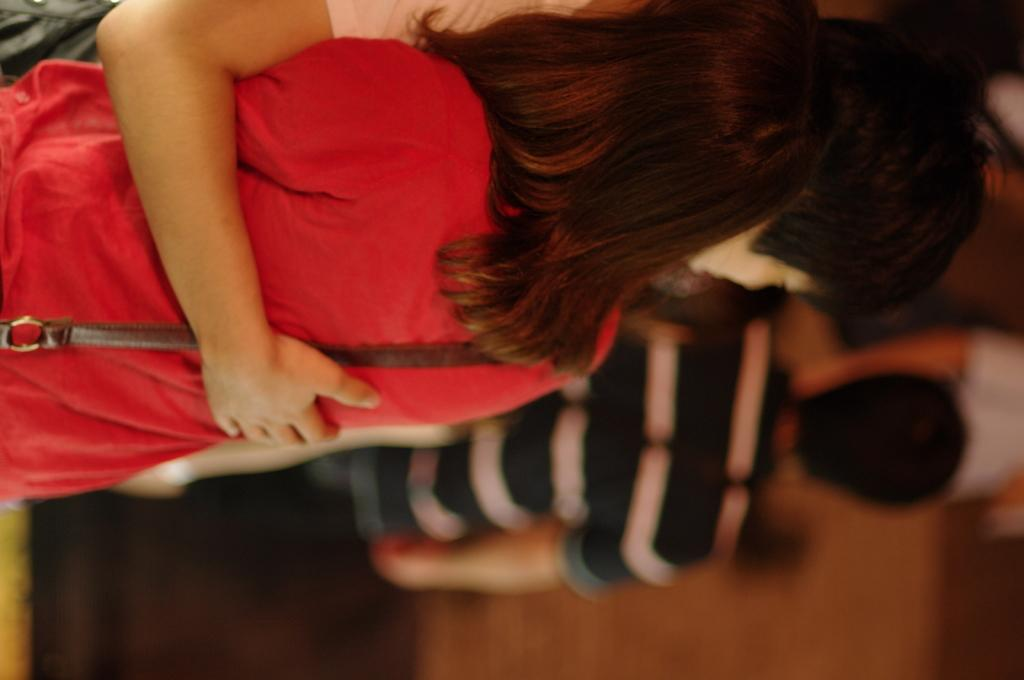What are the two people in the foreground of the image doing? The two people are standing and holding each other. What can be seen in the background of the image? In the background, there are people visible. How would you describe the appearance of the background? The background appears blurry. How many crows can be seen in the image? There are no crows present in the image. What type of ray is visible in the image? There is no ray present in the image. 